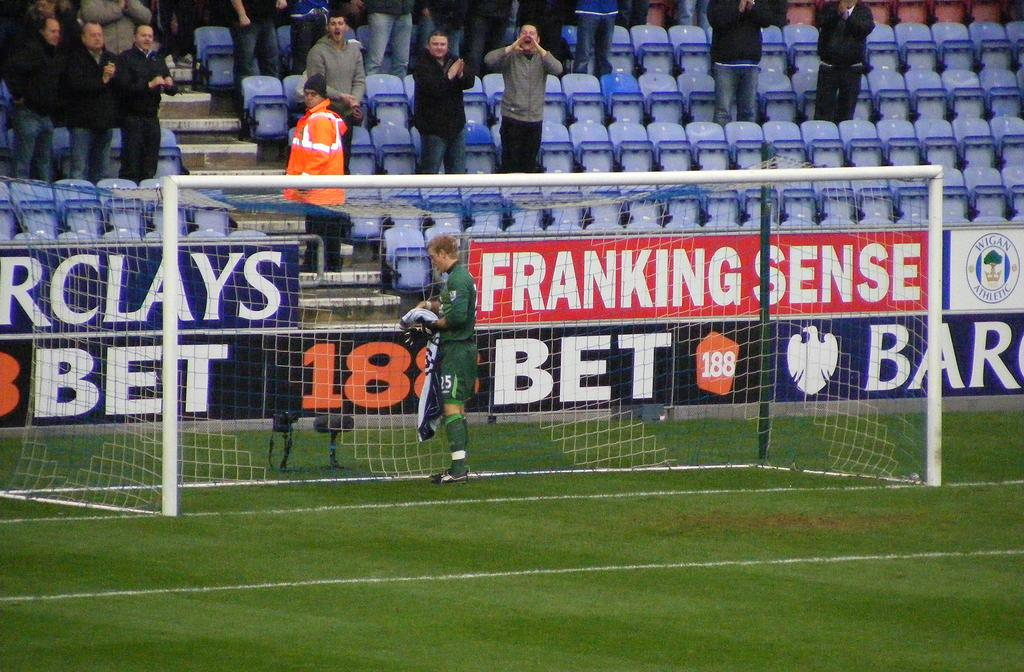<image>
Summarize the visual content of the image. soccer goalie wearing green near signs for franking sense, 188 bet and barclays 